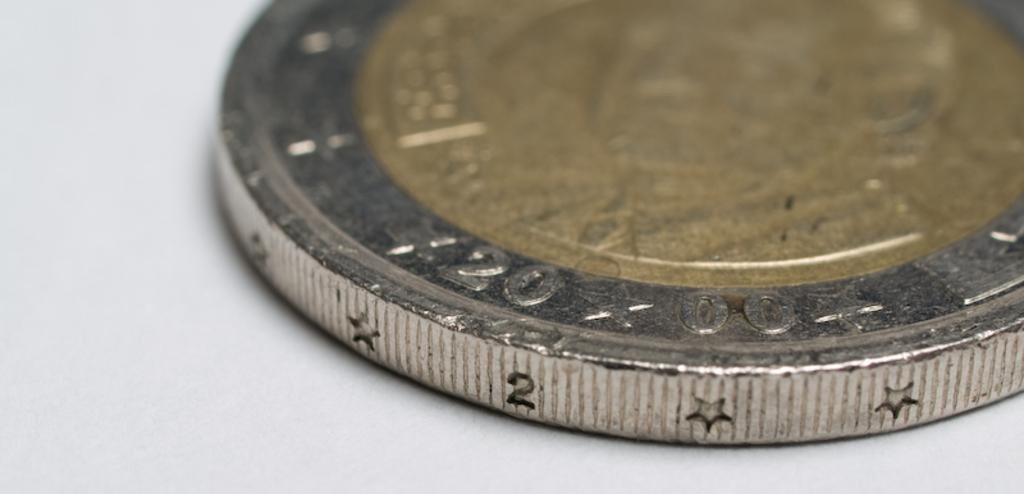<image>
Create a compact narrative representing the image presented. A coin minted in 2000 that features stars on the ridge. 